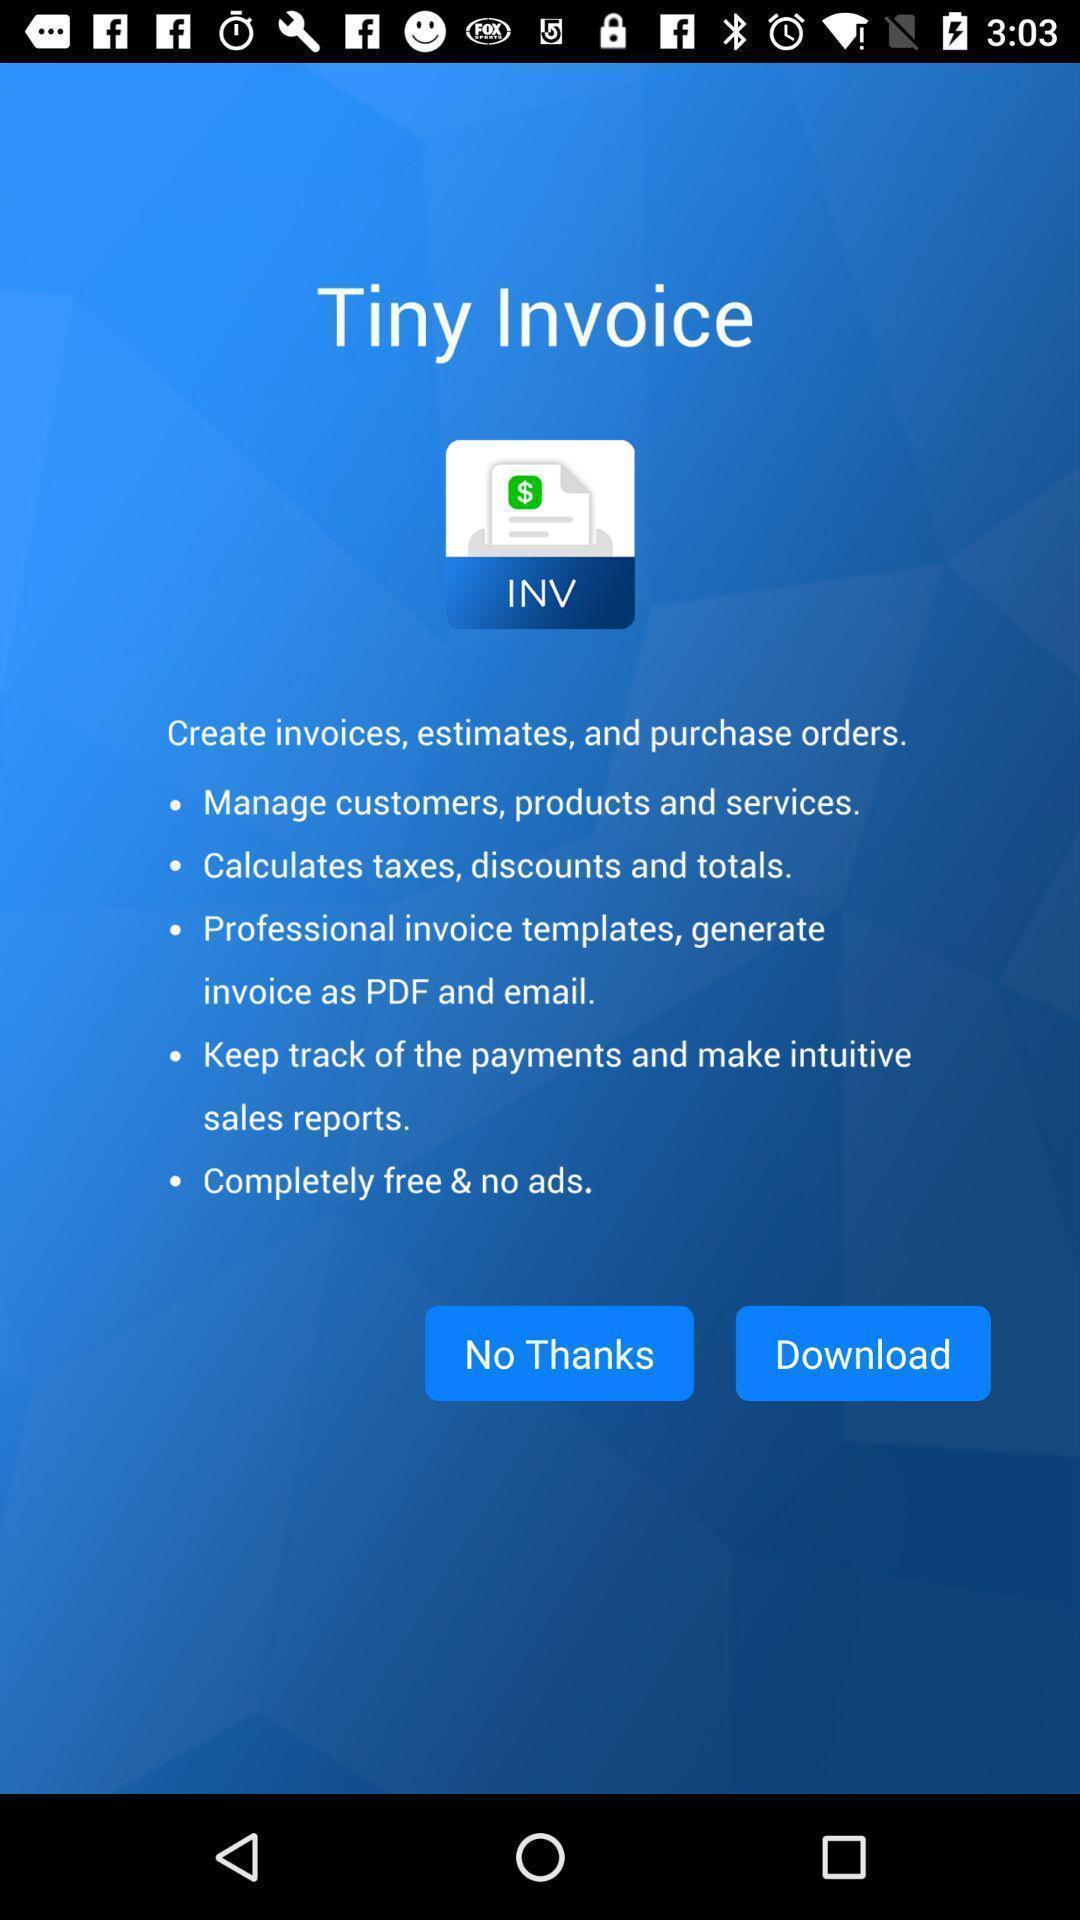Give me a narrative description of this picture. Welcome page with different options. 